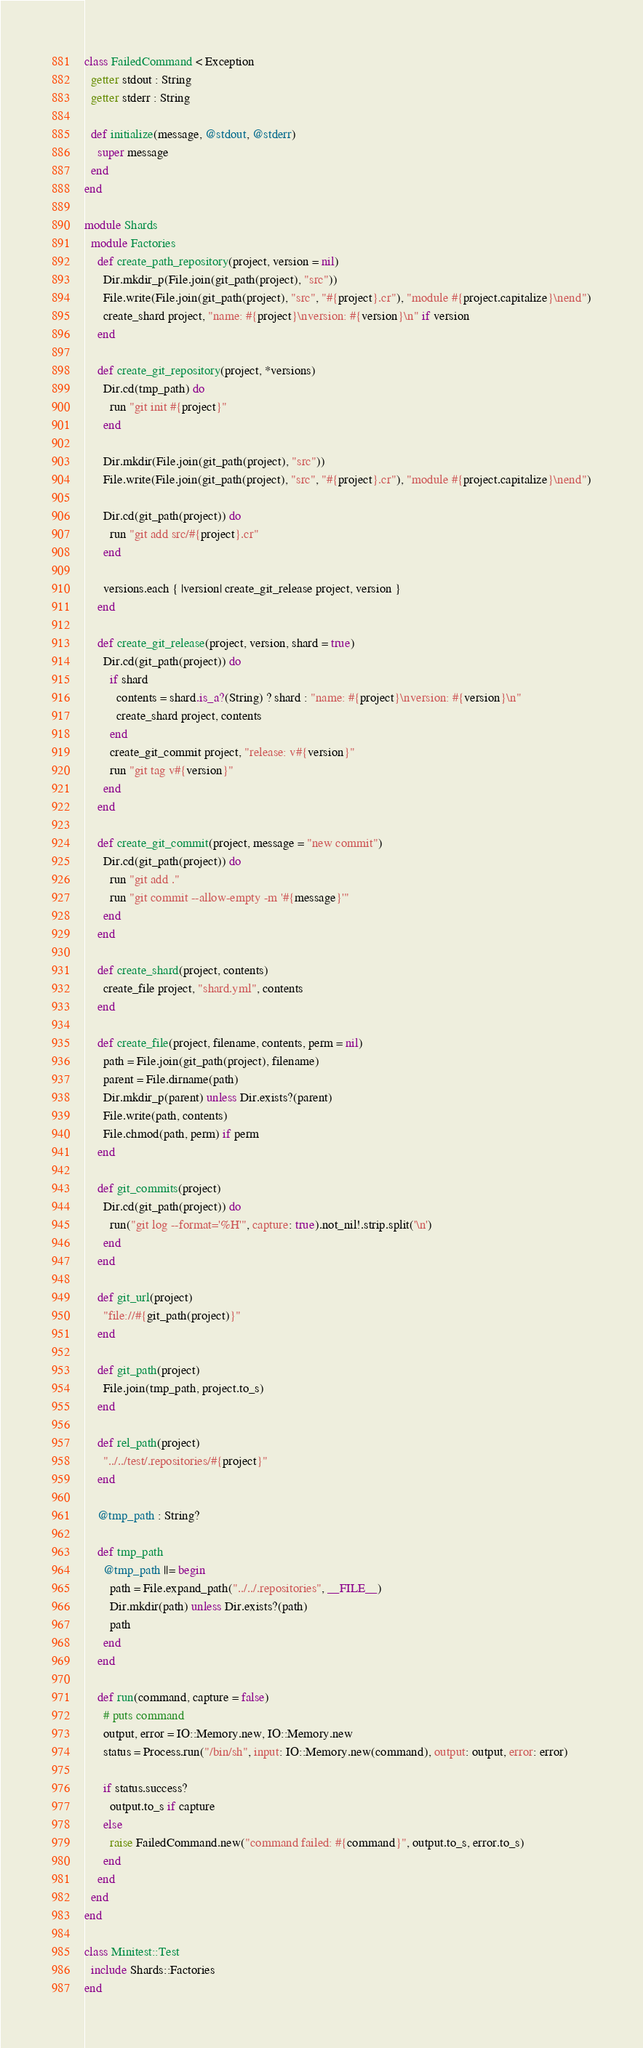<code> <loc_0><loc_0><loc_500><loc_500><_Crystal_>class FailedCommand < Exception
  getter stdout : String
  getter stderr : String

  def initialize(message, @stdout, @stderr)
    super message
  end
end

module Shards
  module Factories
    def create_path_repository(project, version = nil)
      Dir.mkdir_p(File.join(git_path(project), "src"))
      File.write(File.join(git_path(project), "src", "#{project}.cr"), "module #{project.capitalize}\nend")
      create_shard project, "name: #{project}\nversion: #{version}\n" if version
    end

    def create_git_repository(project, *versions)
      Dir.cd(tmp_path) do
        run "git init #{project}"
      end

      Dir.mkdir(File.join(git_path(project), "src"))
      File.write(File.join(git_path(project), "src", "#{project}.cr"), "module #{project.capitalize}\nend")

      Dir.cd(git_path(project)) do
        run "git add src/#{project}.cr"
      end

      versions.each { |version| create_git_release project, version }
    end

    def create_git_release(project, version, shard = true)
      Dir.cd(git_path(project)) do
        if shard
          contents = shard.is_a?(String) ? shard : "name: #{project}\nversion: #{version}\n"
          create_shard project, contents
        end
        create_git_commit project, "release: v#{version}"
        run "git tag v#{version}"
      end
    end

    def create_git_commit(project, message = "new commit")
      Dir.cd(git_path(project)) do
        run "git add ."
        run "git commit --allow-empty -m '#{message}'"
      end
    end

    def create_shard(project, contents)
      create_file project, "shard.yml", contents
    end

    def create_file(project, filename, contents, perm = nil)
      path = File.join(git_path(project), filename)
      parent = File.dirname(path)
      Dir.mkdir_p(parent) unless Dir.exists?(parent)
      File.write(path, contents)
      File.chmod(path, perm) if perm
    end

    def git_commits(project)
      Dir.cd(git_path(project)) do
        run("git log --format='%H'", capture: true).not_nil!.strip.split('\n')
      end
    end

    def git_url(project)
      "file://#{git_path(project)}"
    end

    def git_path(project)
      File.join(tmp_path, project.to_s)
    end

    def rel_path(project)
      "../../test/.repositories/#{project}"
    end

    @tmp_path : String?

    def tmp_path
      @tmp_path ||= begin
        path = File.expand_path("../../.repositories", __FILE__)
        Dir.mkdir(path) unless Dir.exists?(path)
        path
      end
    end

    def run(command, capture = false)
      # puts command
      output, error = IO::Memory.new, IO::Memory.new
      status = Process.run("/bin/sh", input: IO::Memory.new(command), output: output, error: error)

      if status.success?
        output.to_s if capture
      else
        raise FailedCommand.new("command failed: #{command}", output.to_s, error.to_s)
      end
    end
  end
end

class Minitest::Test
  include Shards::Factories
end
</code> 